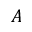<formula> <loc_0><loc_0><loc_500><loc_500>A</formula> 